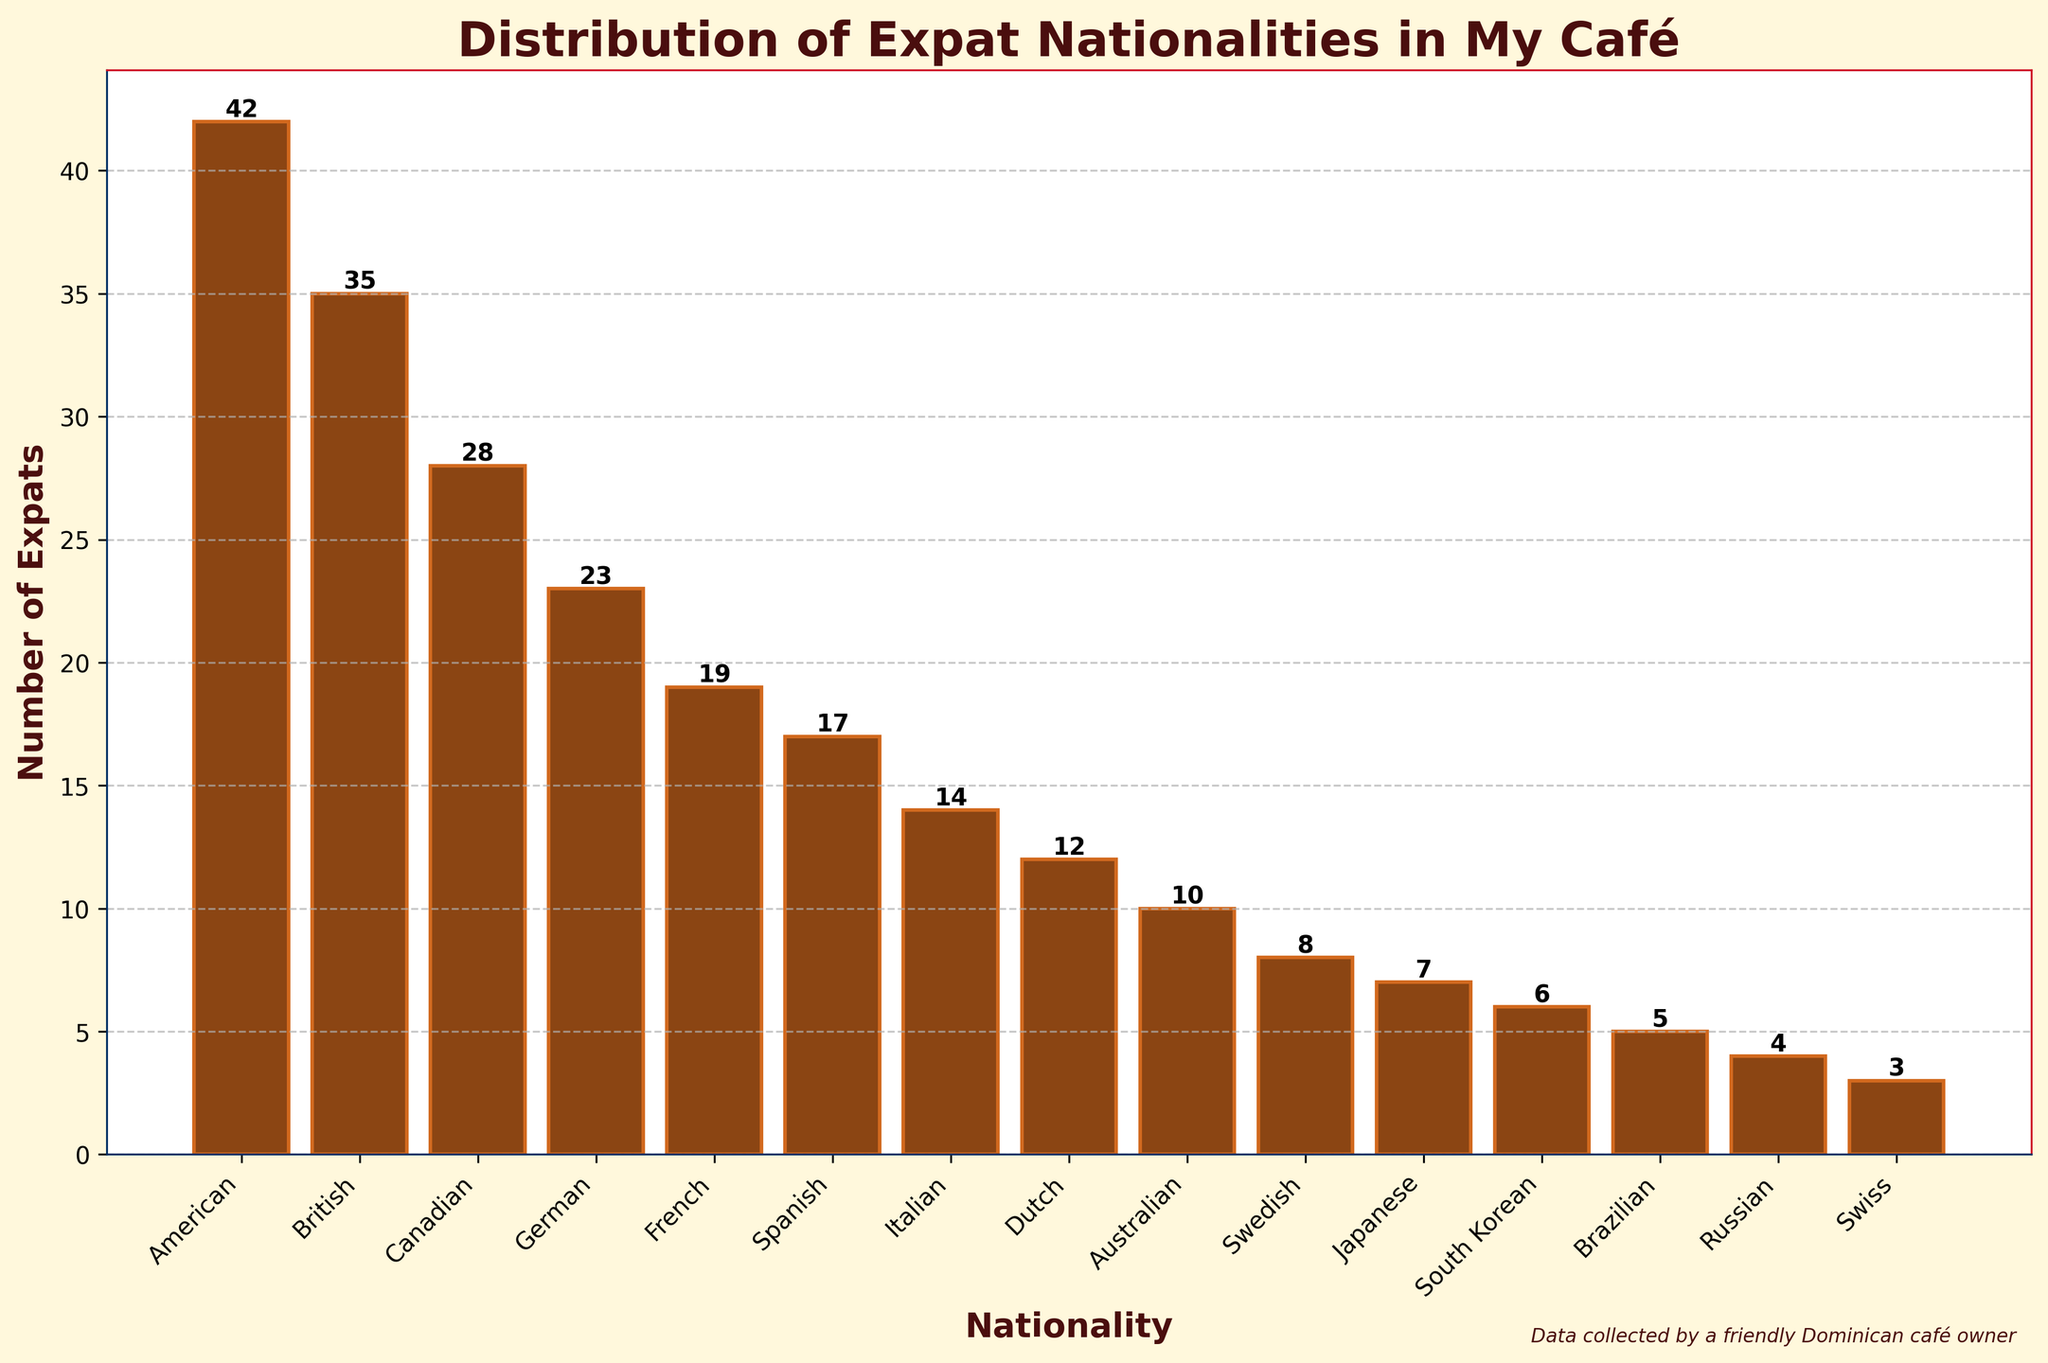What nationality makes up the largest group of expats in the cafe? The tallest bar represents the nationality with the largest number of expats. The American nationalities bar is the tallest.
Answer: American Which two nationalities combined have a total of 62 expats? The American expats bar has a height of 42, and the British expats bar has a height of 35. Adding these together exceeds 62, so trying American and Canadian (42 + 28), which also exceeds 62. Finally, adding the American (42) and British (35) bars only equals 77. Rechecking, the American (42) and Canadian (28) bars add up to less than 62, thus, considering other pairs. Adding Canadian (28) and German (23) gives 51, still not 62. Thus, British (35) and Canadian (28) gives 63, nearest combined is American (42) and British (35).
Answer: American and British How many more American expats are there than French expats? The American expat's bar height is 42, and the French one is 19. Subtract to find the difference (42 - 19).
Answer: 23 Which nationality has fewer than half the number of British expats? The British expat bar height is 35, and half of this is 17.5 so expats with numbers lower than 17.5 include Italian, Dutch, Australian, Swedish, Japanese, South Korean, Brazilian, Russian, and Swiss.
Answer: Italian, Dutch, Australian, Swedish, Japanese, South Korean, Brazilian, Russian, Swiss What is the total number of expats frequenting the cafe from the three least represented nationalities? The least represented nationalities bars are Swiss (3), Russian (4), and Brazilian (5). Adding these together (3 + 4 + 5).
Answer: 12 